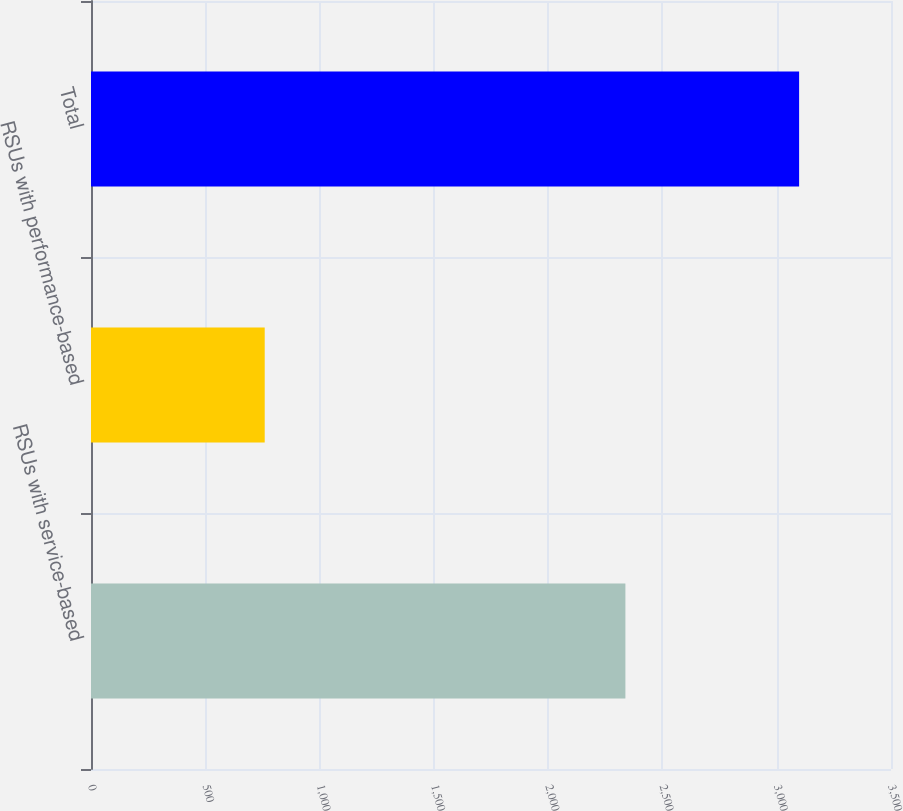Convert chart to OTSL. <chart><loc_0><loc_0><loc_500><loc_500><bar_chart><fcel>RSUs with service-based<fcel>RSUs with performance-based<fcel>Total<nl><fcel>2338<fcel>760<fcel>3098<nl></chart> 